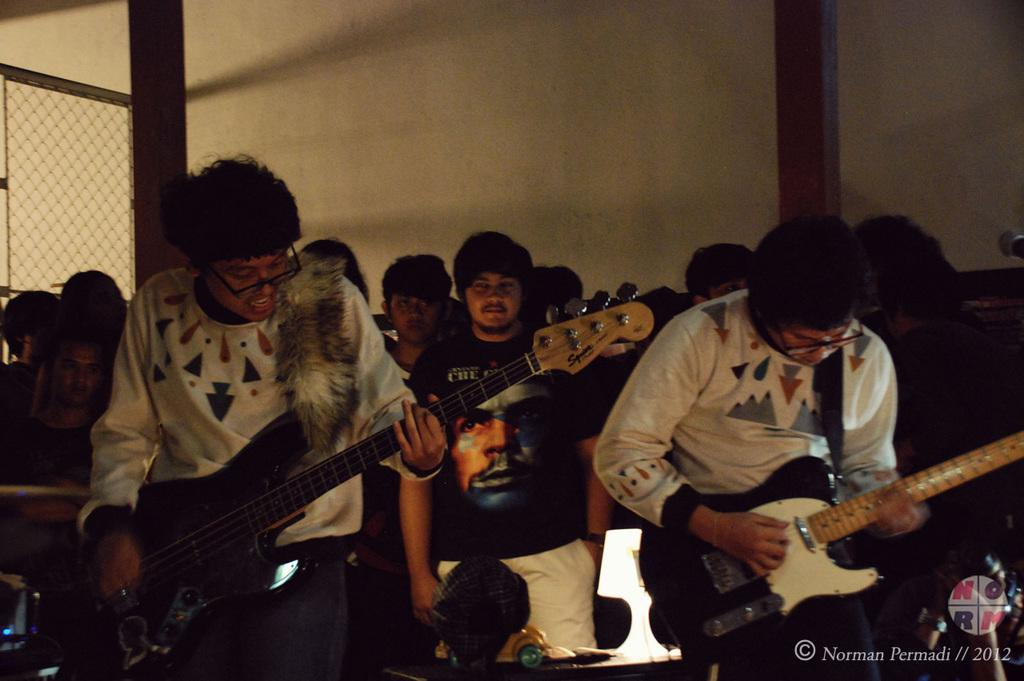What are the people in the image doing? The people in the image are playing guitar. How many people are playing guitar in the image? The facts do not specify the exact number of people playing guitar, but there is a group of people present. What can be seen in the background of the image? There is a wall and a railing in the background of the image. What class of animals are causing the guitar strings to vibrate in the image? There is no mention of any animals causing the guitar strings to vibrate in the image. The people in the image are playing guitar themselves. 